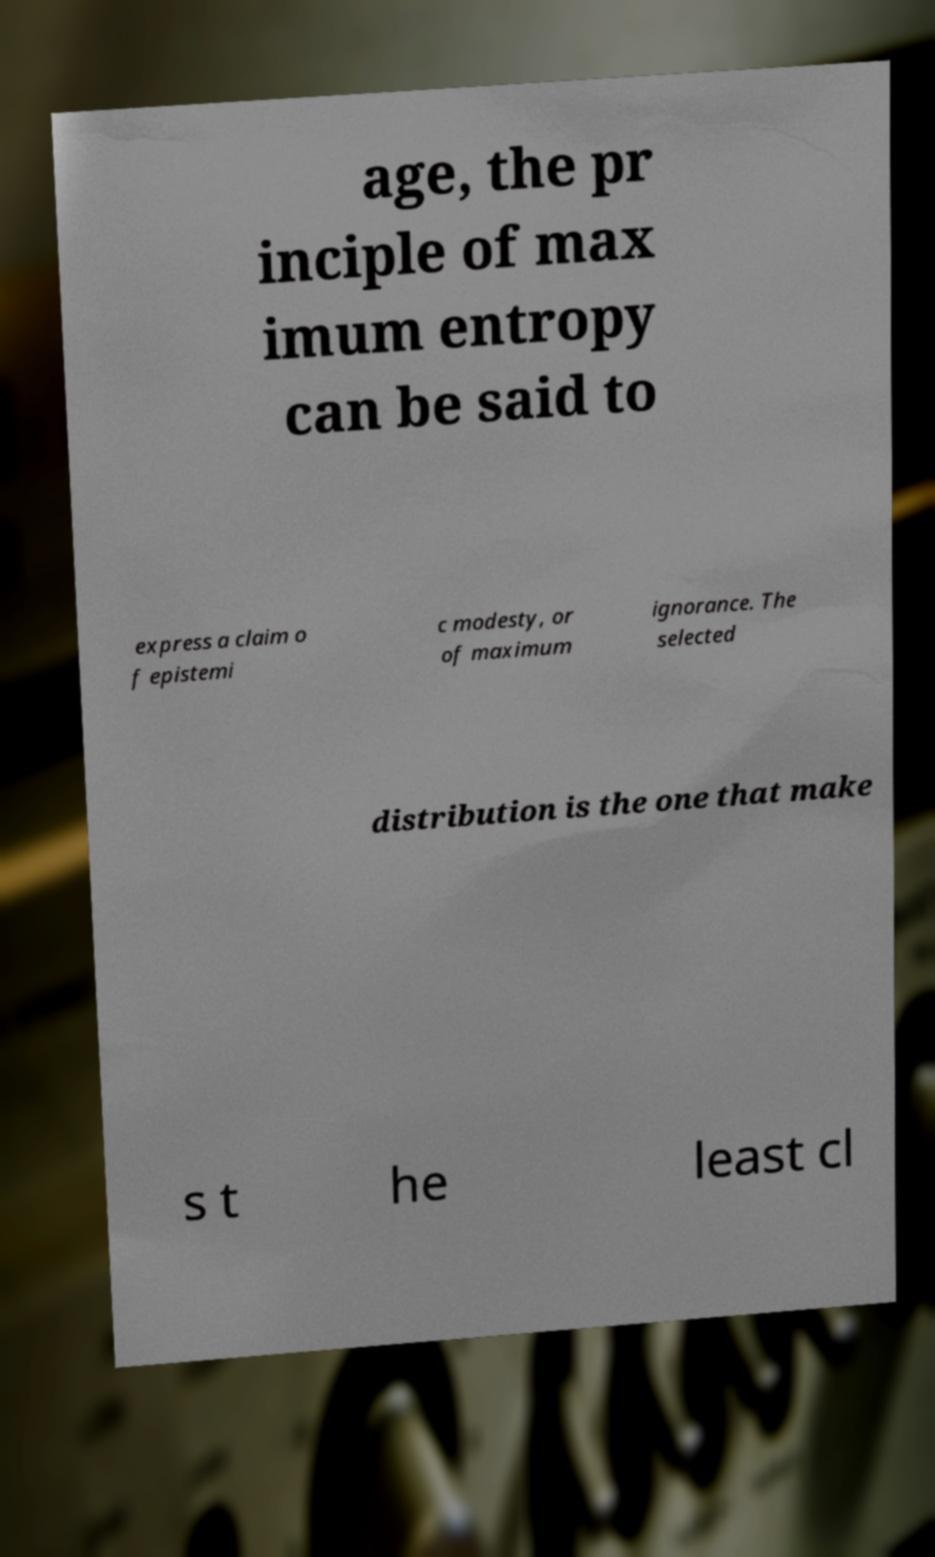There's text embedded in this image that I need extracted. Can you transcribe it verbatim? age, the pr inciple of max imum entropy can be said to express a claim o f epistemi c modesty, or of maximum ignorance. The selected distribution is the one that make s t he least cl 